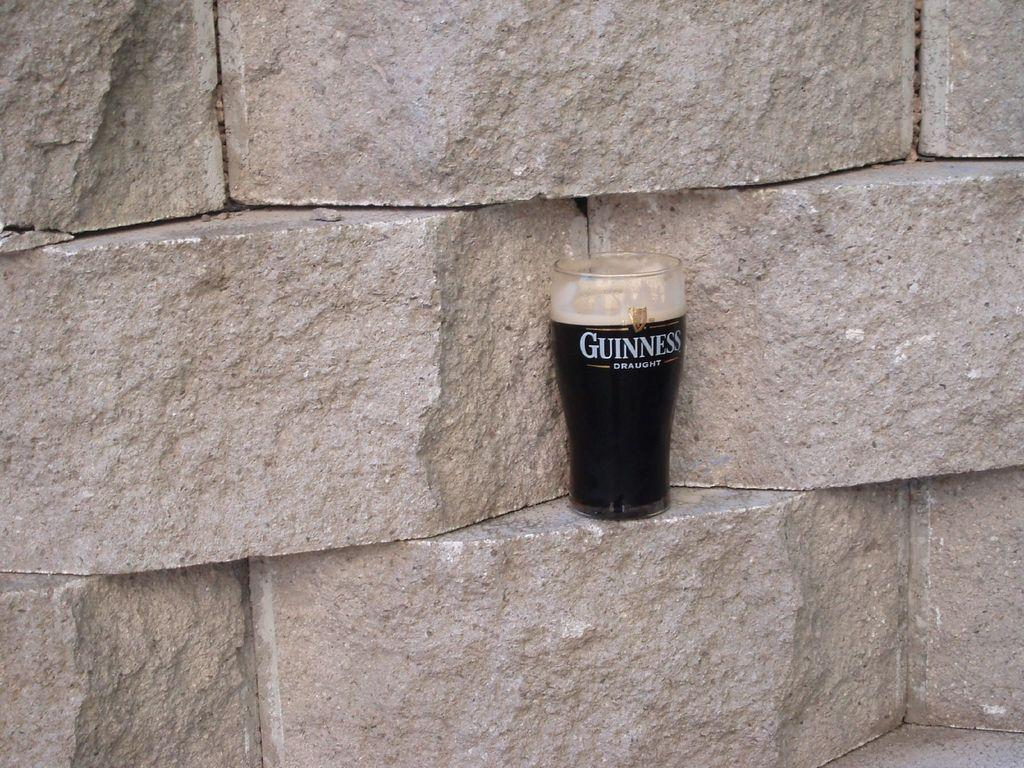<image>
Relay a brief, clear account of the picture shown. A glass of Guinness beer sitting on a brick 